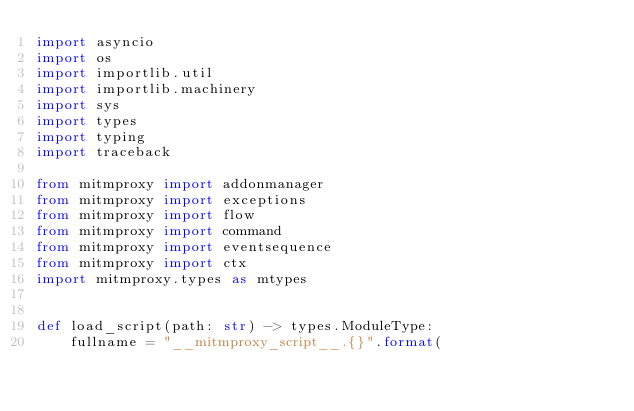Convert code to text. <code><loc_0><loc_0><loc_500><loc_500><_Python_>import asyncio
import os
import importlib.util
import importlib.machinery
import sys
import types
import typing
import traceback

from mitmproxy import addonmanager
from mitmproxy import exceptions
from mitmproxy import flow
from mitmproxy import command
from mitmproxy import eventsequence
from mitmproxy import ctx
import mitmproxy.types as mtypes


def load_script(path: str) -> types.ModuleType:
    fullname = "__mitmproxy_script__.{}".format(</code> 